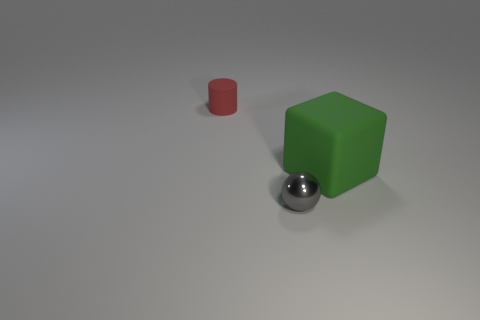Add 1 green cubes. How many objects exist? 4 Subtract all blocks. How many objects are left? 2 Add 1 gray balls. How many gray balls exist? 2 Subtract 0 blue cylinders. How many objects are left? 3 Subtract all green blocks. Subtract all red rubber cylinders. How many objects are left? 1 Add 1 tiny red cylinders. How many tiny red cylinders are left? 2 